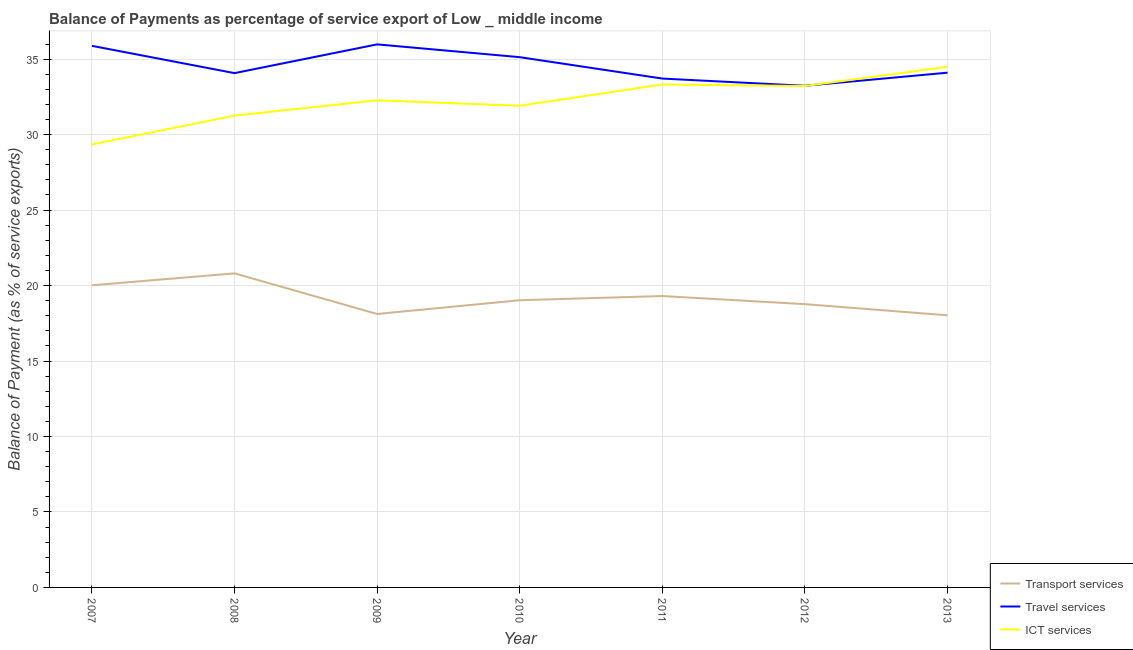Does the line corresponding to balance of payment of transport services intersect with the line corresponding to balance of payment of ict services?
Your answer should be compact. No. Is the number of lines equal to the number of legend labels?
Your response must be concise. Yes. What is the balance of payment of travel services in 2008?
Your answer should be compact. 34.07. Across all years, what is the maximum balance of payment of ict services?
Make the answer very short. 34.49. Across all years, what is the minimum balance of payment of transport services?
Your answer should be compact. 18.03. In which year was the balance of payment of ict services maximum?
Your response must be concise. 2013. In which year was the balance of payment of ict services minimum?
Offer a terse response. 2007. What is the total balance of payment of travel services in the graph?
Make the answer very short. 242.11. What is the difference between the balance of payment of ict services in 2007 and that in 2013?
Keep it short and to the point. -5.14. What is the difference between the balance of payment of transport services in 2011 and the balance of payment of ict services in 2009?
Provide a succinct answer. -12.97. What is the average balance of payment of ict services per year?
Provide a short and direct response. 32.26. In the year 2008, what is the difference between the balance of payment of travel services and balance of payment of transport services?
Your answer should be compact. 13.27. What is the ratio of the balance of payment of travel services in 2008 to that in 2010?
Your response must be concise. 0.97. Is the balance of payment of transport services in 2007 less than that in 2009?
Your answer should be compact. No. Is the difference between the balance of payment of transport services in 2009 and 2013 greater than the difference between the balance of payment of ict services in 2009 and 2013?
Offer a terse response. Yes. What is the difference between the highest and the second highest balance of payment of ict services?
Provide a succinct answer. 1.17. What is the difference between the highest and the lowest balance of payment of transport services?
Offer a terse response. 2.78. In how many years, is the balance of payment of travel services greater than the average balance of payment of travel services taken over all years?
Keep it short and to the point. 3. Is the sum of the balance of payment of travel services in 2007 and 2009 greater than the maximum balance of payment of transport services across all years?
Your answer should be compact. Yes. What is the difference between two consecutive major ticks on the Y-axis?
Your response must be concise. 5. Does the graph contain any zero values?
Ensure brevity in your answer.  No. Does the graph contain grids?
Offer a terse response. Yes. How are the legend labels stacked?
Offer a very short reply. Vertical. What is the title of the graph?
Offer a terse response. Balance of Payments as percentage of service export of Low _ middle income. Does "Unpaid family workers" appear as one of the legend labels in the graph?
Make the answer very short. No. What is the label or title of the Y-axis?
Offer a very short reply. Balance of Payment (as % of service exports). What is the Balance of Payment (as % of service exports) in Transport services in 2007?
Your answer should be compact. 20.02. What is the Balance of Payment (as % of service exports) of Travel services in 2007?
Your response must be concise. 35.88. What is the Balance of Payment (as % of service exports) of ICT services in 2007?
Give a very brief answer. 29.34. What is the Balance of Payment (as % of service exports) of Transport services in 2008?
Your answer should be compact. 20.81. What is the Balance of Payment (as % of service exports) in Travel services in 2008?
Provide a short and direct response. 34.07. What is the Balance of Payment (as % of service exports) of ICT services in 2008?
Provide a short and direct response. 31.26. What is the Balance of Payment (as % of service exports) in Transport services in 2009?
Offer a very short reply. 18.12. What is the Balance of Payment (as % of service exports) of Travel services in 2009?
Keep it short and to the point. 35.98. What is the Balance of Payment (as % of service exports) of ICT services in 2009?
Offer a terse response. 32.27. What is the Balance of Payment (as % of service exports) in Transport services in 2010?
Provide a short and direct response. 19.03. What is the Balance of Payment (as % of service exports) of Travel services in 2010?
Your answer should be compact. 35.13. What is the Balance of Payment (as % of service exports) of ICT services in 2010?
Your answer should be compact. 31.91. What is the Balance of Payment (as % of service exports) of Transport services in 2011?
Offer a very short reply. 19.31. What is the Balance of Payment (as % of service exports) in Travel services in 2011?
Provide a succinct answer. 33.71. What is the Balance of Payment (as % of service exports) of ICT services in 2011?
Provide a succinct answer. 33.32. What is the Balance of Payment (as % of service exports) in Transport services in 2012?
Your response must be concise. 18.77. What is the Balance of Payment (as % of service exports) in Travel services in 2012?
Your response must be concise. 33.23. What is the Balance of Payment (as % of service exports) in ICT services in 2012?
Keep it short and to the point. 33.22. What is the Balance of Payment (as % of service exports) of Transport services in 2013?
Keep it short and to the point. 18.03. What is the Balance of Payment (as % of service exports) in Travel services in 2013?
Your response must be concise. 34.1. What is the Balance of Payment (as % of service exports) in ICT services in 2013?
Make the answer very short. 34.49. Across all years, what is the maximum Balance of Payment (as % of service exports) of Transport services?
Provide a short and direct response. 20.81. Across all years, what is the maximum Balance of Payment (as % of service exports) of Travel services?
Keep it short and to the point. 35.98. Across all years, what is the maximum Balance of Payment (as % of service exports) in ICT services?
Give a very brief answer. 34.49. Across all years, what is the minimum Balance of Payment (as % of service exports) of Transport services?
Your answer should be compact. 18.03. Across all years, what is the minimum Balance of Payment (as % of service exports) in Travel services?
Offer a terse response. 33.23. Across all years, what is the minimum Balance of Payment (as % of service exports) in ICT services?
Offer a very short reply. 29.34. What is the total Balance of Payment (as % of service exports) in Transport services in the graph?
Provide a short and direct response. 134.07. What is the total Balance of Payment (as % of service exports) of Travel services in the graph?
Offer a very short reply. 242.11. What is the total Balance of Payment (as % of service exports) in ICT services in the graph?
Offer a terse response. 225.82. What is the difference between the Balance of Payment (as % of service exports) of Transport services in 2007 and that in 2008?
Your answer should be compact. -0.79. What is the difference between the Balance of Payment (as % of service exports) in Travel services in 2007 and that in 2008?
Ensure brevity in your answer.  1.81. What is the difference between the Balance of Payment (as % of service exports) of ICT services in 2007 and that in 2008?
Offer a terse response. -1.91. What is the difference between the Balance of Payment (as % of service exports) of Transport services in 2007 and that in 2009?
Your answer should be compact. 1.9. What is the difference between the Balance of Payment (as % of service exports) of Travel services in 2007 and that in 2009?
Your answer should be very brief. -0.1. What is the difference between the Balance of Payment (as % of service exports) in ICT services in 2007 and that in 2009?
Offer a very short reply. -2.93. What is the difference between the Balance of Payment (as % of service exports) in Transport services in 2007 and that in 2010?
Provide a short and direct response. 0.99. What is the difference between the Balance of Payment (as % of service exports) of Travel services in 2007 and that in 2010?
Ensure brevity in your answer.  0.75. What is the difference between the Balance of Payment (as % of service exports) of ICT services in 2007 and that in 2010?
Give a very brief answer. -2.57. What is the difference between the Balance of Payment (as % of service exports) in Transport services in 2007 and that in 2011?
Offer a terse response. 0.71. What is the difference between the Balance of Payment (as % of service exports) of Travel services in 2007 and that in 2011?
Your answer should be very brief. 2.17. What is the difference between the Balance of Payment (as % of service exports) in ICT services in 2007 and that in 2011?
Your answer should be compact. -3.98. What is the difference between the Balance of Payment (as % of service exports) of Transport services in 2007 and that in 2012?
Offer a terse response. 1.25. What is the difference between the Balance of Payment (as % of service exports) of Travel services in 2007 and that in 2012?
Make the answer very short. 2.65. What is the difference between the Balance of Payment (as % of service exports) in ICT services in 2007 and that in 2012?
Your answer should be compact. -3.87. What is the difference between the Balance of Payment (as % of service exports) in Transport services in 2007 and that in 2013?
Make the answer very short. 1.99. What is the difference between the Balance of Payment (as % of service exports) of Travel services in 2007 and that in 2013?
Keep it short and to the point. 1.78. What is the difference between the Balance of Payment (as % of service exports) in ICT services in 2007 and that in 2013?
Offer a very short reply. -5.14. What is the difference between the Balance of Payment (as % of service exports) in Transport services in 2008 and that in 2009?
Offer a terse response. 2.69. What is the difference between the Balance of Payment (as % of service exports) in Travel services in 2008 and that in 2009?
Give a very brief answer. -1.91. What is the difference between the Balance of Payment (as % of service exports) of ICT services in 2008 and that in 2009?
Make the answer very short. -1.02. What is the difference between the Balance of Payment (as % of service exports) of Transport services in 2008 and that in 2010?
Your answer should be very brief. 1.78. What is the difference between the Balance of Payment (as % of service exports) of Travel services in 2008 and that in 2010?
Provide a short and direct response. -1.06. What is the difference between the Balance of Payment (as % of service exports) in ICT services in 2008 and that in 2010?
Ensure brevity in your answer.  -0.66. What is the difference between the Balance of Payment (as % of service exports) of Transport services in 2008 and that in 2011?
Keep it short and to the point. 1.5. What is the difference between the Balance of Payment (as % of service exports) of Travel services in 2008 and that in 2011?
Give a very brief answer. 0.36. What is the difference between the Balance of Payment (as % of service exports) of ICT services in 2008 and that in 2011?
Provide a succinct answer. -2.06. What is the difference between the Balance of Payment (as % of service exports) in Transport services in 2008 and that in 2012?
Make the answer very short. 2.04. What is the difference between the Balance of Payment (as % of service exports) of Travel services in 2008 and that in 2012?
Give a very brief answer. 0.84. What is the difference between the Balance of Payment (as % of service exports) in ICT services in 2008 and that in 2012?
Keep it short and to the point. -1.96. What is the difference between the Balance of Payment (as % of service exports) in Transport services in 2008 and that in 2013?
Offer a very short reply. 2.78. What is the difference between the Balance of Payment (as % of service exports) in Travel services in 2008 and that in 2013?
Your answer should be compact. -0.03. What is the difference between the Balance of Payment (as % of service exports) of ICT services in 2008 and that in 2013?
Provide a short and direct response. -3.23. What is the difference between the Balance of Payment (as % of service exports) in Transport services in 2009 and that in 2010?
Your answer should be very brief. -0.91. What is the difference between the Balance of Payment (as % of service exports) of Travel services in 2009 and that in 2010?
Ensure brevity in your answer.  0.85. What is the difference between the Balance of Payment (as % of service exports) of ICT services in 2009 and that in 2010?
Give a very brief answer. 0.36. What is the difference between the Balance of Payment (as % of service exports) of Transport services in 2009 and that in 2011?
Offer a terse response. -1.19. What is the difference between the Balance of Payment (as % of service exports) in Travel services in 2009 and that in 2011?
Make the answer very short. 2.27. What is the difference between the Balance of Payment (as % of service exports) of ICT services in 2009 and that in 2011?
Ensure brevity in your answer.  -1.05. What is the difference between the Balance of Payment (as % of service exports) of Transport services in 2009 and that in 2012?
Your answer should be very brief. -0.65. What is the difference between the Balance of Payment (as % of service exports) in Travel services in 2009 and that in 2012?
Offer a terse response. 2.74. What is the difference between the Balance of Payment (as % of service exports) of ICT services in 2009 and that in 2012?
Provide a succinct answer. -0.95. What is the difference between the Balance of Payment (as % of service exports) in Transport services in 2009 and that in 2013?
Your answer should be compact. 0.09. What is the difference between the Balance of Payment (as % of service exports) in Travel services in 2009 and that in 2013?
Ensure brevity in your answer.  1.88. What is the difference between the Balance of Payment (as % of service exports) of ICT services in 2009 and that in 2013?
Offer a terse response. -2.22. What is the difference between the Balance of Payment (as % of service exports) of Transport services in 2010 and that in 2011?
Provide a succinct answer. -0.28. What is the difference between the Balance of Payment (as % of service exports) in Travel services in 2010 and that in 2011?
Give a very brief answer. 1.42. What is the difference between the Balance of Payment (as % of service exports) in ICT services in 2010 and that in 2011?
Ensure brevity in your answer.  -1.41. What is the difference between the Balance of Payment (as % of service exports) of Transport services in 2010 and that in 2012?
Offer a very short reply. 0.26. What is the difference between the Balance of Payment (as % of service exports) of Travel services in 2010 and that in 2012?
Your response must be concise. 1.9. What is the difference between the Balance of Payment (as % of service exports) of ICT services in 2010 and that in 2012?
Give a very brief answer. -1.31. What is the difference between the Balance of Payment (as % of service exports) of Transport services in 2010 and that in 2013?
Your response must be concise. 1. What is the difference between the Balance of Payment (as % of service exports) of Travel services in 2010 and that in 2013?
Make the answer very short. 1.03. What is the difference between the Balance of Payment (as % of service exports) of ICT services in 2010 and that in 2013?
Your response must be concise. -2.58. What is the difference between the Balance of Payment (as % of service exports) of Transport services in 2011 and that in 2012?
Your response must be concise. 0.54. What is the difference between the Balance of Payment (as % of service exports) in Travel services in 2011 and that in 2012?
Offer a terse response. 0.48. What is the difference between the Balance of Payment (as % of service exports) in ICT services in 2011 and that in 2012?
Provide a short and direct response. 0.1. What is the difference between the Balance of Payment (as % of service exports) in Transport services in 2011 and that in 2013?
Provide a succinct answer. 1.28. What is the difference between the Balance of Payment (as % of service exports) in Travel services in 2011 and that in 2013?
Provide a succinct answer. -0.39. What is the difference between the Balance of Payment (as % of service exports) of ICT services in 2011 and that in 2013?
Provide a succinct answer. -1.17. What is the difference between the Balance of Payment (as % of service exports) of Transport services in 2012 and that in 2013?
Make the answer very short. 0.74. What is the difference between the Balance of Payment (as % of service exports) of Travel services in 2012 and that in 2013?
Ensure brevity in your answer.  -0.87. What is the difference between the Balance of Payment (as % of service exports) in ICT services in 2012 and that in 2013?
Give a very brief answer. -1.27. What is the difference between the Balance of Payment (as % of service exports) in Transport services in 2007 and the Balance of Payment (as % of service exports) in Travel services in 2008?
Your response must be concise. -14.06. What is the difference between the Balance of Payment (as % of service exports) of Transport services in 2007 and the Balance of Payment (as % of service exports) of ICT services in 2008?
Keep it short and to the point. -11.24. What is the difference between the Balance of Payment (as % of service exports) of Travel services in 2007 and the Balance of Payment (as % of service exports) of ICT services in 2008?
Your answer should be compact. 4.62. What is the difference between the Balance of Payment (as % of service exports) of Transport services in 2007 and the Balance of Payment (as % of service exports) of Travel services in 2009?
Make the answer very short. -15.96. What is the difference between the Balance of Payment (as % of service exports) in Transport services in 2007 and the Balance of Payment (as % of service exports) in ICT services in 2009?
Ensure brevity in your answer.  -12.26. What is the difference between the Balance of Payment (as % of service exports) in Travel services in 2007 and the Balance of Payment (as % of service exports) in ICT services in 2009?
Provide a succinct answer. 3.61. What is the difference between the Balance of Payment (as % of service exports) in Transport services in 2007 and the Balance of Payment (as % of service exports) in Travel services in 2010?
Ensure brevity in your answer.  -15.11. What is the difference between the Balance of Payment (as % of service exports) of Transport services in 2007 and the Balance of Payment (as % of service exports) of ICT services in 2010?
Your answer should be compact. -11.9. What is the difference between the Balance of Payment (as % of service exports) of Travel services in 2007 and the Balance of Payment (as % of service exports) of ICT services in 2010?
Your response must be concise. 3.97. What is the difference between the Balance of Payment (as % of service exports) in Transport services in 2007 and the Balance of Payment (as % of service exports) in Travel services in 2011?
Your answer should be compact. -13.7. What is the difference between the Balance of Payment (as % of service exports) of Transport services in 2007 and the Balance of Payment (as % of service exports) of ICT services in 2011?
Offer a very short reply. -13.3. What is the difference between the Balance of Payment (as % of service exports) in Travel services in 2007 and the Balance of Payment (as % of service exports) in ICT services in 2011?
Ensure brevity in your answer.  2.56. What is the difference between the Balance of Payment (as % of service exports) of Transport services in 2007 and the Balance of Payment (as % of service exports) of Travel services in 2012?
Make the answer very short. -13.22. What is the difference between the Balance of Payment (as % of service exports) in Transport services in 2007 and the Balance of Payment (as % of service exports) in ICT services in 2012?
Provide a short and direct response. -13.2. What is the difference between the Balance of Payment (as % of service exports) of Travel services in 2007 and the Balance of Payment (as % of service exports) of ICT services in 2012?
Keep it short and to the point. 2.66. What is the difference between the Balance of Payment (as % of service exports) of Transport services in 2007 and the Balance of Payment (as % of service exports) of Travel services in 2013?
Provide a succinct answer. -14.09. What is the difference between the Balance of Payment (as % of service exports) in Transport services in 2007 and the Balance of Payment (as % of service exports) in ICT services in 2013?
Offer a very short reply. -14.47. What is the difference between the Balance of Payment (as % of service exports) of Travel services in 2007 and the Balance of Payment (as % of service exports) of ICT services in 2013?
Your answer should be compact. 1.39. What is the difference between the Balance of Payment (as % of service exports) in Transport services in 2008 and the Balance of Payment (as % of service exports) in Travel services in 2009?
Your answer should be compact. -15.17. What is the difference between the Balance of Payment (as % of service exports) in Transport services in 2008 and the Balance of Payment (as % of service exports) in ICT services in 2009?
Offer a very short reply. -11.47. What is the difference between the Balance of Payment (as % of service exports) in Travel services in 2008 and the Balance of Payment (as % of service exports) in ICT services in 2009?
Your response must be concise. 1.8. What is the difference between the Balance of Payment (as % of service exports) in Transport services in 2008 and the Balance of Payment (as % of service exports) in Travel services in 2010?
Keep it short and to the point. -14.32. What is the difference between the Balance of Payment (as % of service exports) of Transport services in 2008 and the Balance of Payment (as % of service exports) of ICT services in 2010?
Your answer should be very brief. -11.11. What is the difference between the Balance of Payment (as % of service exports) of Travel services in 2008 and the Balance of Payment (as % of service exports) of ICT services in 2010?
Provide a short and direct response. 2.16. What is the difference between the Balance of Payment (as % of service exports) of Transport services in 2008 and the Balance of Payment (as % of service exports) of Travel services in 2011?
Make the answer very short. -12.91. What is the difference between the Balance of Payment (as % of service exports) in Transport services in 2008 and the Balance of Payment (as % of service exports) in ICT services in 2011?
Make the answer very short. -12.51. What is the difference between the Balance of Payment (as % of service exports) in Travel services in 2008 and the Balance of Payment (as % of service exports) in ICT services in 2011?
Your answer should be very brief. 0.75. What is the difference between the Balance of Payment (as % of service exports) in Transport services in 2008 and the Balance of Payment (as % of service exports) in Travel services in 2012?
Ensure brevity in your answer.  -12.43. What is the difference between the Balance of Payment (as % of service exports) in Transport services in 2008 and the Balance of Payment (as % of service exports) in ICT services in 2012?
Offer a terse response. -12.41. What is the difference between the Balance of Payment (as % of service exports) of Travel services in 2008 and the Balance of Payment (as % of service exports) of ICT services in 2012?
Provide a succinct answer. 0.85. What is the difference between the Balance of Payment (as % of service exports) in Transport services in 2008 and the Balance of Payment (as % of service exports) in Travel services in 2013?
Provide a short and direct response. -13.3. What is the difference between the Balance of Payment (as % of service exports) in Transport services in 2008 and the Balance of Payment (as % of service exports) in ICT services in 2013?
Your response must be concise. -13.68. What is the difference between the Balance of Payment (as % of service exports) of Travel services in 2008 and the Balance of Payment (as % of service exports) of ICT services in 2013?
Keep it short and to the point. -0.42. What is the difference between the Balance of Payment (as % of service exports) in Transport services in 2009 and the Balance of Payment (as % of service exports) in Travel services in 2010?
Your answer should be compact. -17.01. What is the difference between the Balance of Payment (as % of service exports) of Transport services in 2009 and the Balance of Payment (as % of service exports) of ICT services in 2010?
Give a very brief answer. -13.8. What is the difference between the Balance of Payment (as % of service exports) in Travel services in 2009 and the Balance of Payment (as % of service exports) in ICT services in 2010?
Keep it short and to the point. 4.07. What is the difference between the Balance of Payment (as % of service exports) in Transport services in 2009 and the Balance of Payment (as % of service exports) in Travel services in 2011?
Ensure brevity in your answer.  -15.6. What is the difference between the Balance of Payment (as % of service exports) of Transport services in 2009 and the Balance of Payment (as % of service exports) of ICT services in 2011?
Provide a short and direct response. -15.2. What is the difference between the Balance of Payment (as % of service exports) in Travel services in 2009 and the Balance of Payment (as % of service exports) in ICT services in 2011?
Your response must be concise. 2.66. What is the difference between the Balance of Payment (as % of service exports) of Transport services in 2009 and the Balance of Payment (as % of service exports) of Travel services in 2012?
Ensure brevity in your answer.  -15.12. What is the difference between the Balance of Payment (as % of service exports) in Transport services in 2009 and the Balance of Payment (as % of service exports) in ICT services in 2012?
Provide a short and direct response. -15.1. What is the difference between the Balance of Payment (as % of service exports) of Travel services in 2009 and the Balance of Payment (as % of service exports) of ICT services in 2012?
Offer a terse response. 2.76. What is the difference between the Balance of Payment (as % of service exports) of Transport services in 2009 and the Balance of Payment (as % of service exports) of Travel services in 2013?
Your response must be concise. -15.99. What is the difference between the Balance of Payment (as % of service exports) in Transport services in 2009 and the Balance of Payment (as % of service exports) in ICT services in 2013?
Ensure brevity in your answer.  -16.37. What is the difference between the Balance of Payment (as % of service exports) in Travel services in 2009 and the Balance of Payment (as % of service exports) in ICT services in 2013?
Provide a short and direct response. 1.49. What is the difference between the Balance of Payment (as % of service exports) in Transport services in 2010 and the Balance of Payment (as % of service exports) in Travel services in 2011?
Give a very brief answer. -14.69. What is the difference between the Balance of Payment (as % of service exports) in Transport services in 2010 and the Balance of Payment (as % of service exports) in ICT services in 2011?
Ensure brevity in your answer.  -14.29. What is the difference between the Balance of Payment (as % of service exports) in Travel services in 2010 and the Balance of Payment (as % of service exports) in ICT services in 2011?
Keep it short and to the point. 1.81. What is the difference between the Balance of Payment (as % of service exports) of Transport services in 2010 and the Balance of Payment (as % of service exports) of Travel services in 2012?
Ensure brevity in your answer.  -14.21. What is the difference between the Balance of Payment (as % of service exports) of Transport services in 2010 and the Balance of Payment (as % of service exports) of ICT services in 2012?
Offer a terse response. -14.19. What is the difference between the Balance of Payment (as % of service exports) of Travel services in 2010 and the Balance of Payment (as % of service exports) of ICT services in 2012?
Give a very brief answer. 1.91. What is the difference between the Balance of Payment (as % of service exports) in Transport services in 2010 and the Balance of Payment (as % of service exports) in Travel services in 2013?
Your answer should be very brief. -15.08. What is the difference between the Balance of Payment (as % of service exports) in Transport services in 2010 and the Balance of Payment (as % of service exports) in ICT services in 2013?
Your answer should be very brief. -15.46. What is the difference between the Balance of Payment (as % of service exports) in Travel services in 2010 and the Balance of Payment (as % of service exports) in ICT services in 2013?
Keep it short and to the point. 0.64. What is the difference between the Balance of Payment (as % of service exports) in Transport services in 2011 and the Balance of Payment (as % of service exports) in Travel services in 2012?
Provide a short and direct response. -13.93. What is the difference between the Balance of Payment (as % of service exports) in Transport services in 2011 and the Balance of Payment (as % of service exports) in ICT services in 2012?
Offer a terse response. -13.91. What is the difference between the Balance of Payment (as % of service exports) of Travel services in 2011 and the Balance of Payment (as % of service exports) of ICT services in 2012?
Provide a short and direct response. 0.49. What is the difference between the Balance of Payment (as % of service exports) of Transport services in 2011 and the Balance of Payment (as % of service exports) of Travel services in 2013?
Offer a very short reply. -14.8. What is the difference between the Balance of Payment (as % of service exports) of Transport services in 2011 and the Balance of Payment (as % of service exports) of ICT services in 2013?
Provide a short and direct response. -15.18. What is the difference between the Balance of Payment (as % of service exports) in Travel services in 2011 and the Balance of Payment (as % of service exports) in ICT services in 2013?
Provide a succinct answer. -0.78. What is the difference between the Balance of Payment (as % of service exports) in Transport services in 2012 and the Balance of Payment (as % of service exports) in Travel services in 2013?
Provide a short and direct response. -15.34. What is the difference between the Balance of Payment (as % of service exports) of Transport services in 2012 and the Balance of Payment (as % of service exports) of ICT services in 2013?
Offer a terse response. -15.72. What is the difference between the Balance of Payment (as % of service exports) in Travel services in 2012 and the Balance of Payment (as % of service exports) in ICT services in 2013?
Keep it short and to the point. -1.25. What is the average Balance of Payment (as % of service exports) of Transport services per year?
Make the answer very short. 19.15. What is the average Balance of Payment (as % of service exports) of Travel services per year?
Keep it short and to the point. 34.59. What is the average Balance of Payment (as % of service exports) in ICT services per year?
Provide a succinct answer. 32.26. In the year 2007, what is the difference between the Balance of Payment (as % of service exports) of Transport services and Balance of Payment (as % of service exports) of Travel services?
Your answer should be very brief. -15.86. In the year 2007, what is the difference between the Balance of Payment (as % of service exports) in Transport services and Balance of Payment (as % of service exports) in ICT services?
Provide a short and direct response. -9.33. In the year 2007, what is the difference between the Balance of Payment (as % of service exports) in Travel services and Balance of Payment (as % of service exports) in ICT services?
Keep it short and to the point. 6.54. In the year 2008, what is the difference between the Balance of Payment (as % of service exports) of Transport services and Balance of Payment (as % of service exports) of Travel services?
Make the answer very short. -13.27. In the year 2008, what is the difference between the Balance of Payment (as % of service exports) in Transport services and Balance of Payment (as % of service exports) in ICT services?
Make the answer very short. -10.45. In the year 2008, what is the difference between the Balance of Payment (as % of service exports) in Travel services and Balance of Payment (as % of service exports) in ICT services?
Your answer should be very brief. 2.82. In the year 2009, what is the difference between the Balance of Payment (as % of service exports) of Transport services and Balance of Payment (as % of service exports) of Travel services?
Give a very brief answer. -17.86. In the year 2009, what is the difference between the Balance of Payment (as % of service exports) of Transport services and Balance of Payment (as % of service exports) of ICT services?
Keep it short and to the point. -14.16. In the year 2009, what is the difference between the Balance of Payment (as % of service exports) in Travel services and Balance of Payment (as % of service exports) in ICT services?
Offer a terse response. 3.7. In the year 2010, what is the difference between the Balance of Payment (as % of service exports) in Transport services and Balance of Payment (as % of service exports) in Travel services?
Offer a terse response. -16.1. In the year 2010, what is the difference between the Balance of Payment (as % of service exports) in Transport services and Balance of Payment (as % of service exports) in ICT services?
Your answer should be very brief. -12.89. In the year 2010, what is the difference between the Balance of Payment (as % of service exports) in Travel services and Balance of Payment (as % of service exports) in ICT services?
Provide a succinct answer. 3.22. In the year 2011, what is the difference between the Balance of Payment (as % of service exports) of Transport services and Balance of Payment (as % of service exports) of Travel services?
Make the answer very short. -14.41. In the year 2011, what is the difference between the Balance of Payment (as % of service exports) of Transport services and Balance of Payment (as % of service exports) of ICT services?
Offer a terse response. -14.02. In the year 2011, what is the difference between the Balance of Payment (as % of service exports) in Travel services and Balance of Payment (as % of service exports) in ICT services?
Ensure brevity in your answer.  0.39. In the year 2012, what is the difference between the Balance of Payment (as % of service exports) in Transport services and Balance of Payment (as % of service exports) in Travel services?
Provide a short and direct response. -14.47. In the year 2012, what is the difference between the Balance of Payment (as % of service exports) in Transport services and Balance of Payment (as % of service exports) in ICT services?
Your answer should be compact. -14.45. In the year 2012, what is the difference between the Balance of Payment (as % of service exports) of Travel services and Balance of Payment (as % of service exports) of ICT services?
Provide a succinct answer. 0.02. In the year 2013, what is the difference between the Balance of Payment (as % of service exports) in Transport services and Balance of Payment (as % of service exports) in Travel services?
Your response must be concise. -16.08. In the year 2013, what is the difference between the Balance of Payment (as % of service exports) in Transport services and Balance of Payment (as % of service exports) in ICT services?
Your response must be concise. -16.46. In the year 2013, what is the difference between the Balance of Payment (as % of service exports) of Travel services and Balance of Payment (as % of service exports) of ICT services?
Ensure brevity in your answer.  -0.39. What is the ratio of the Balance of Payment (as % of service exports) of Transport services in 2007 to that in 2008?
Offer a very short reply. 0.96. What is the ratio of the Balance of Payment (as % of service exports) of Travel services in 2007 to that in 2008?
Your answer should be compact. 1.05. What is the ratio of the Balance of Payment (as % of service exports) in ICT services in 2007 to that in 2008?
Your answer should be very brief. 0.94. What is the ratio of the Balance of Payment (as % of service exports) in Transport services in 2007 to that in 2009?
Offer a terse response. 1.1. What is the ratio of the Balance of Payment (as % of service exports) in Travel services in 2007 to that in 2009?
Make the answer very short. 1. What is the ratio of the Balance of Payment (as % of service exports) in ICT services in 2007 to that in 2009?
Ensure brevity in your answer.  0.91. What is the ratio of the Balance of Payment (as % of service exports) in Transport services in 2007 to that in 2010?
Offer a very short reply. 1.05. What is the ratio of the Balance of Payment (as % of service exports) of Travel services in 2007 to that in 2010?
Your answer should be compact. 1.02. What is the ratio of the Balance of Payment (as % of service exports) of ICT services in 2007 to that in 2010?
Give a very brief answer. 0.92. What is the ratio of the Balance of Payment (as % of service exports) in Transport services in 2007 to that in 2011?
Offer a very short reply. 1.04. What is the ratio of the Balance of Payment (as % of service exports) of Travel services in 2007 to that in 2011?
Your answer should be very brief. 1.06. What is the ratio of the Balance of Payment (as % of service exports) of ICT services in 2007 to that in 2011?
Your response must be concise. 0.88. What is the ratio of the Balance of Payment (as % of service exports) of Transport services in 2007 to that in 2012?
Provide a short and direct response. 1.07. What is the ratio of the Balance of Payment (as % of service exports) in Travel services in 2007 to that in 2012?
Provide a short and direct response. 1.08. What is the ratio of the Balance of Payment (as % of service exports) in ICT services in 2007 to that in 2012?
Your answer should be compact. 0.88. What is the ratio of the Balance of Payment (as % of service exports) in Transport services in 2007 to that in 2013?
Make the answer very short. 1.11. What is the ratio of the Balance of Payment (as % of service exports) in Travel services in 2007 to that in 2013?
Offer a terse response. 1.05. What is the ratio of the Balance of Payment (as % of service exports) of ICT services in 2007 to that in 2013?
Ensure brevity in your answer.  0.85. What is the ratio of the Balance of Payment (as % of service exports) in Transport services in 2008 to that in 2009?
Your response must be concise. 1.15. What is the ratio of the Balance of Payment (as % of service exports) in Travel services in 2008 to that in 2009?
Offer a very short reply. 0.95. What is the ratio of the Balance of Payment (as % of service exports) of ICT services in 2008 to that in 2009?
Offer a terse response. 0.97. What is the ratio of the Balance of Payment (as % of service exports) of Transport services in 2008 to that in 2010?
Your answer should be compact. 1.09. What is the ratio of the Balance of Payment (as % of service exports) in Travel services in 2008 to that in 2010?
Your answer should be compact. 0.97. What is the ratio of the Balance of Payment (as % of service exports) of ICT services in 2008 to that in 2010?
Provide a short and direct response. 0.98. What is the ratio of the Balance of Payment (as % of service exports) of Transport services in 2008 to that in 2011?
Offer a very short reply. 1.08. What is the ratio of the Balance of Payment (as % of service exports) in Travel services in 2008 to that in 2011?
Your response must be concise. 1.01. What is the ratio of the Balance of Payment (as % of service exports) in ICT services in 2008 to that in 2011?
Your answer should be compact. 0.94. What is the ratio of the Balance of Payment (as % of service exports) of Transport services in 2008 to that in 2012?
Your response must be concise. 1.11. What is the ratio of the Balance of Payment (as % of service exports) in Travel services in 2008 to that in 2012?
Provide a short and direct response. 1.03. What is the ratio of the Balance of Payment (as % of service exports) in ICT services in 2008 to that in 2012?
Your answer should be very brief. 0.94. What is the ratio of the Balance of Payment (as % of service exports) of Transport services in 2008 to that in 2013?
Your response must be concise. 1.15. What is the ratio of the Balance of Payment (as % of service exports) in ICT services in 2008 to that in 2013?
Give a very brief answer. 0.91. What is the ratio of the Balance of Payment (as % of service exports) in Transport services in 2009 to that in 2010?
Make the answer very short. 0.95. What is the ratio of the Balance of Payment (as % of service exports) in Travel services in 2009 to that in 2010?
Offer a very short reply. 1.02. What is the ratio of the Balance of Payment (as % of service exports) in ICT services in 2009 to that in 2010?
Make the answer very short. 1.01. What is the ratio of the Balance of Payment (as % of service exports) of Transport services in 2009 to that in 2011?
Offer a very short reply. 0.94. What is the ratio of the Balance of Payment (as % of service exports) of Travel services in 2009 to that in 2011?
Offer a terse response. 1.07. What is the ratio of the Balance of Payment (as % of service exports) of ICT services in 2009 to that in 2011?
Provide a succinct answer. 0.97. What is the ratio of the Balance of Payment (as % of service exports) of Transport services in 2009 to that in 2012?
Your answer should be very brief. 0.97. What is the ratio of the Balance of Payment (as % of service exports) in Travel services in 2009 to that in 2012?
Provide a succinct answer. 1.08. What is the ratio of the Balance of Payment (as % of service exports) in ICT services in 2009 to that in 2012?
Provide a succinct answer. 0.97. What is the ratio of the Balance of Payment (as % of service exports) in Travel services in 2009 to that in 2013?
Provide a short and direct response. 1.05. What is the ratio of the Balance of Payment (as % of service exports) in ICT services in 2009 to that in 2013?
Give a very brief answer. 0.94. What is the ratio of the Balance of Payment (as % of service exports) of Transport services in 2010 to that in 2011?
Ensure brevity in your answer.  0.99. What is the ratio of the Balance of Payment (as % of service exports) in Travel services in 2010 to that in 2011?
Offer a very short reply. 1.04. What is the ratio of the Balance of Payment (as % of service exports) of ICT services in 2010 to that in 2011?
Your response must be concise. 0.96. What is the ratio of the Balance of Payment (as % of service exports) of Transport services in 2010 to that in 2012?
Provide a short and direct response. 1.01. What is the ratio of the Balance of Payment (as % of service exports) of Travel services in 2010 to that in 2012?
Give a very brief answer. 1.06. What is the ratio of the Balance of Payment (as % of service exports) of ICT services in 2010 to that in 2012?
Give a very brief answer. 0.96. What is the ratio of the Balance of Payment (as % of service exports) in Transport services in 2010 to that in 2013?
Give a very brief answer. 1.06. What is the ratio of the Balance of Payment (as % of service exports) in Travel services in 2010 to that in 2013?
Your answer should be compact. 1.03. What is the ratio of the Balance of Payment (as % of service exports) in ICT services in 2010 to that in 2013?
Provide a succinct answer. 0.93. What is the ratio of the Balance of Payment (as % of service exports) in Transport services in 2011 to that in 2012?
Ensure brevity in your answer.  1.03. What is the ratio of the Balance of Payment (as % of service exports) in Travel services in 2011 to that in 2012?
Offer a very short reply. 1.01. What is the ratio of the Balance of Payment (as % of service exports) of Transport services in 2011 to that in 2013?
Provide a short and direct response. 1.07. What is the ratio of the Balance of Payment (as % of service exports) in ICT services in 2011 to that in 2013?
Offer a very short reply. 0.97. What is the ratio of the Balance of Payment (as % of service exports) of Transport services in 2012 to that in 2013?
Offer a very short reply. 1.04. What is the ratio of the Balance of Payment (as % of service exports) in Travel services in 2012 to that in 2013?
Your answer should be very brief. 0.97. What is the ratio of the Balance of Payment (as % of service exports) of ICT services in 2012 to that in 2013?
Your answer should be very brief. 0.96. What is the difference between the highest and the second highest Balance of Payment (as % of service exports) of Transport services?
Give a very brief answer. 0.79. What is the difference between the highest and the second highest Balance of Payment (as % of service exports) of Travel services?
Make the answer very short. 0.1. What is the difference between the highest and the second highest Balance of Payment (as % of service exports) of ICT services?
Provide a short and direct response. 1.17. What is the difference between the highest and the lowest Balance of Payment (as % of service exports) of Transport services?
Keep it short and to the point. 2.78. What is the difference between the highest and the lowest Balance of Payment (as % of service exports) of Travel services?
Provide a succinct answer. 2.74. What is the difference between the highest and the lowest Balance of Payment (as % of service exports) of ICT services?
Make the answer very short. 5.14. 